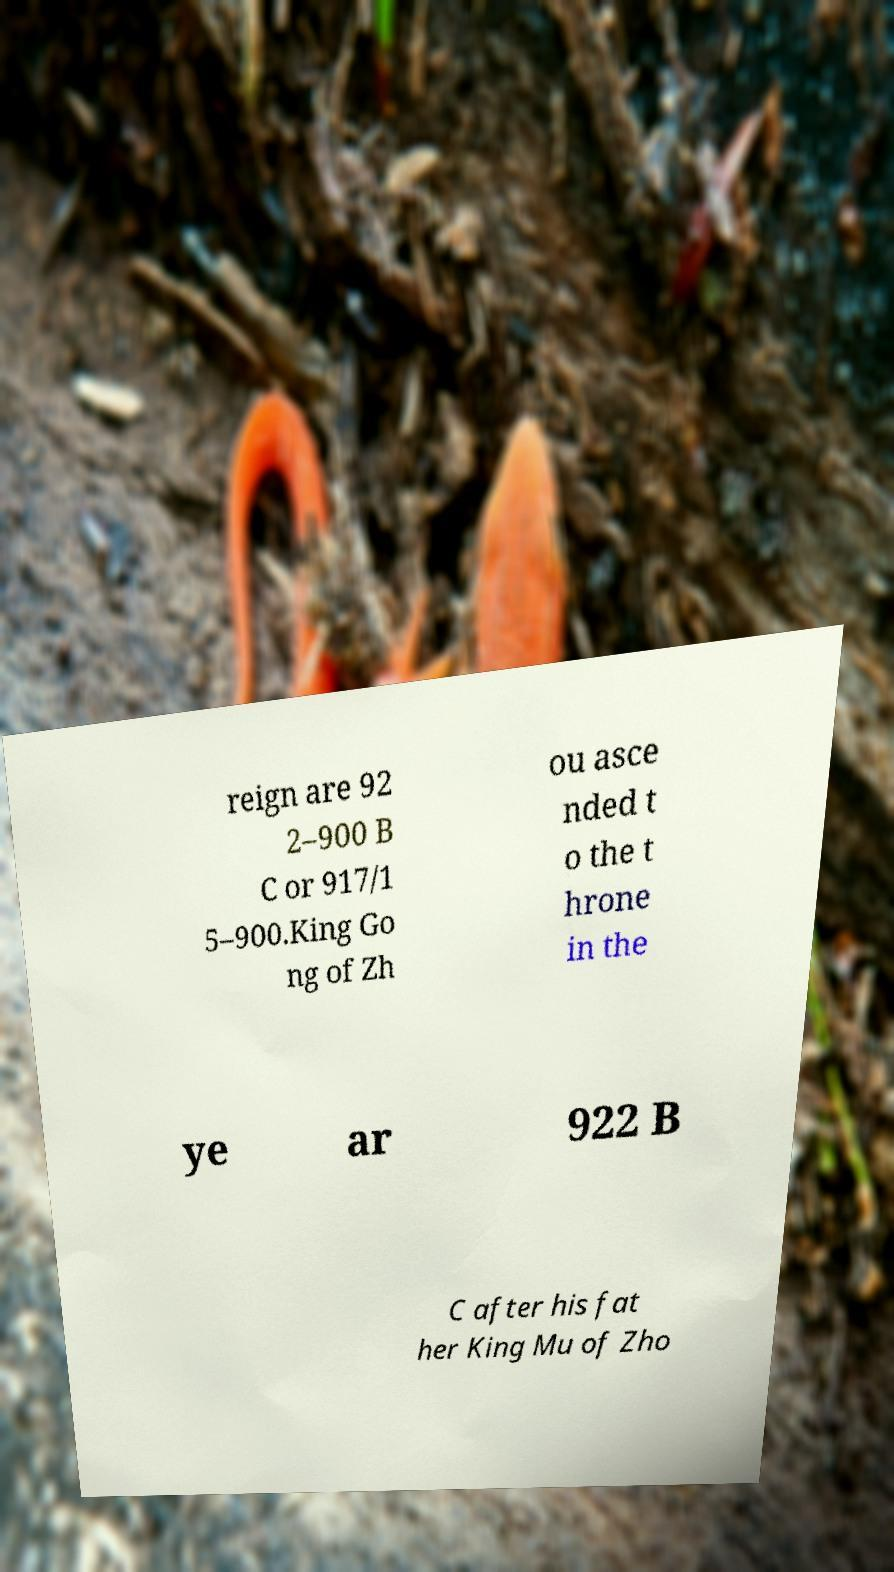Please identify and transcribe the text found in this image. reign are 92 2–900 B C or 917/1 5–900.King Go ng of Zh ou asce nded t o the t hrone in the ye ar 922 B C after his fat her King Mu of Zho 